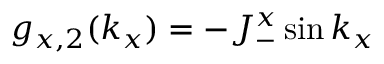Convert formula to latex. <formula><loc_0><loc_0><loc_500><loc_500>g _ { x , 2 } ( k _ { x } ) = - J _ { - } ^ { x } \sin k _ { x }</formula> 